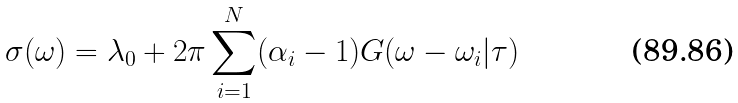<formula> <loc_0><loc_0><loc_500><loc_500>\sigma ( \omega ) = \lambda _ { 0 } + 2 \pi \sum _ { i = 1 } ^ { N } ( \alpha _ { i } - 1 ) G ( \omega - \omega _ { i } | \tau )</formula> 